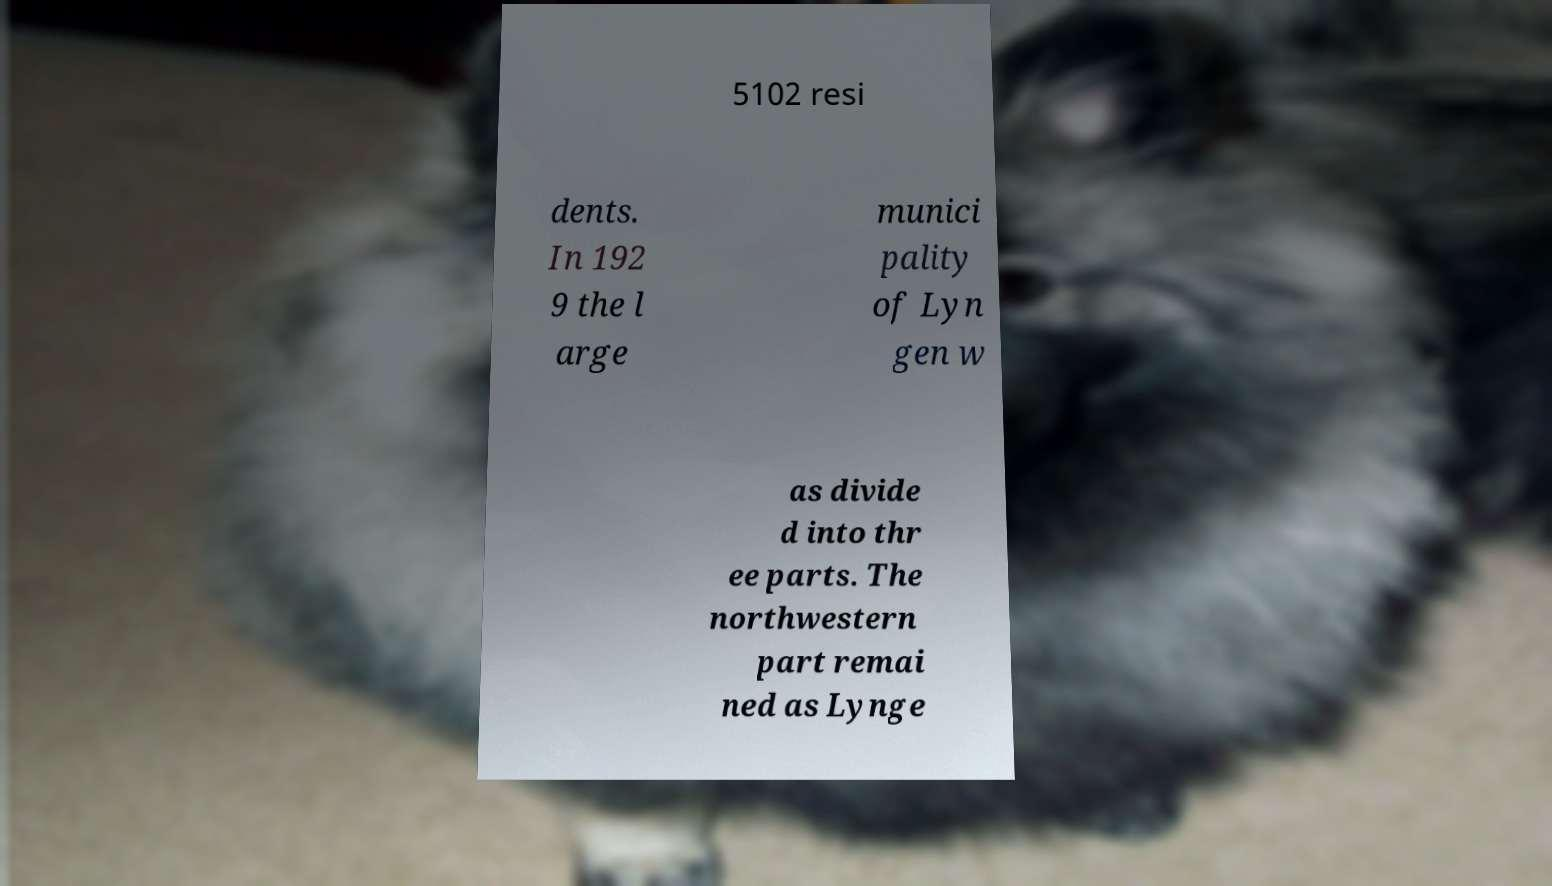There's text embedded in this image that I need extracted. Can you transcribe it verbatim? 5102 resi dents. In 192 9 the l arge munici pality of Lyn gen w as divide d into thr ee parts. The northwestern part remai ned as Lynge 